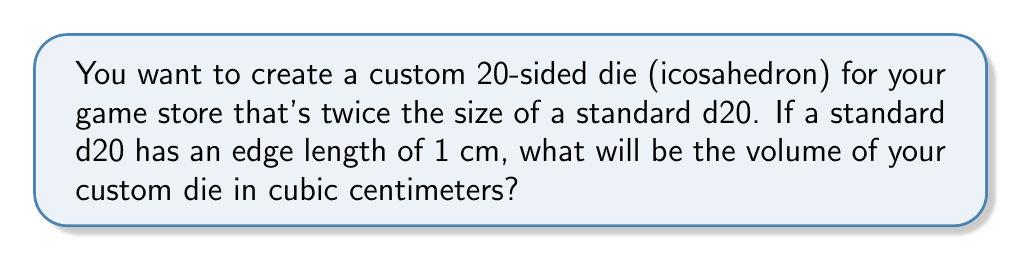Show me your answer to this math problem. Let's approach this step-by-step:

1) The volume of an icosahedron is given by the formula:

   $$V = \frac{5(3+\sqrt{5})}{12}a^3$$

   where $a$ is the length of an edge.

2) We're told that the custom die is twice the size of a standard die. This means all dimensions are doubled, including the edge length. So if the standard die has an edge length of 1 cm, our custom die has an edge length of 2 cm.

3) Let's substitute $a = 2$ into our volume formula:

   $$V = \frac{5(3+\sqrt{5})}{12}(2^3)$$

4) Simplify the cube:
   
   $$V = \frac{5(3+\sqrt{5})}{12}(8)$$

5) Multiply:

   $$V = \frac{40(3+\sqrt{5})}{12}$$

6) Simplify:

   $$V = \frac{10(3+\sqrt{5})}{3}$$

7) Calculate the value (rounded to two decimal places):

   $$V \approx 18.51 \text{ cm}^3$$
Answer: $18.51 \text{ cm}^3$ 